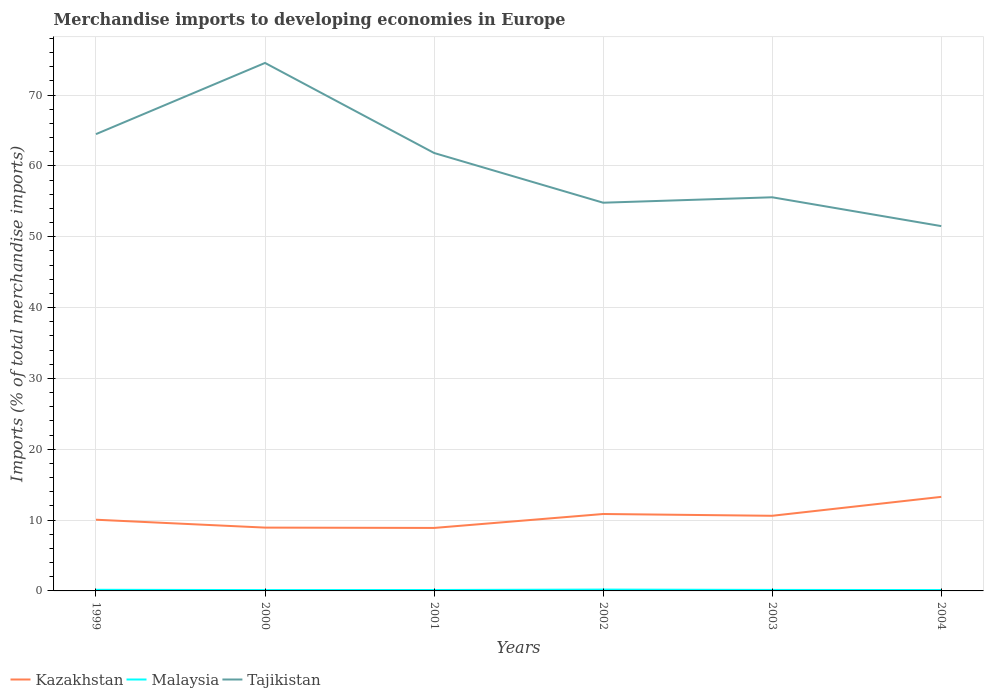Is the number of lines equal to the number of legend labels?
Offer a terse response. Yes. Across all years, what is the maximum percentage total merchandise imports in Malaysia?
Offer a very short reply. 0.12. In which year was the percentage total merchandise imports in Malaysia maximum?
Your response must be concise. 2000. What is the total percentage total merchandise imports in Malaysia in the graph?
Your response must be concise. -0. What is the difference between the highest and the second highest percentage total merchandise imports in Tajikistan?
Give a very brief answer. 23.04. What is the difference between the highest and the lowest percentage total merchandise imports in Malaysia?
Make the answer very short. 2. Is the percentage total merchandise imports in Tajikistan strictly greater than the percentage total merchandise imports in Malaysia over the years?
Keep it short and to the point. No. Are the values on the major ticks of Y-axis written in scientific E-notation?
Ensure brevity in your answer.  No. Where does the legend appear in the graph?
Offer a terse response. Bottom left. How many legend labels are there?
Provide a short and direct response. 3. How are the legend labels stacked?
Ensure brevity in your answer.  Horizontal. What is the title of the graph?
Provide a short and direct response. Merchandise imports to developing economies in Europe. What is the label or title of the X-axis?
Make the answer very short. Years. What is the label or title of the Y-axis?
Offer a very short reply. Imports (% of total merchandise imports). What is the Imports (% of total merchandise imports) of Kazakhstan in 1999?
Provide a short and direct response. 10.05. What is the Imports (% of total merchandise imports) of Malaysia in 1999?
Ensure brevity in your answer.  0.16. What is the Imports (% of total merchandise imports) of Tajikistan in 1999?
Give a very brief answer. 64.49. What is the Imports (% of total merchandise imports) in Kazakhstan in 2000?
Offer a very short reply. 8.94. What is the Imports (% of total merchandise imports) in Malaysia in 2000?
Your answer should be very brief. 0.12. What is the Imports (% of total merchandise imports) of Tajikistan in 2000?
Your answer should be compact. 74.54. What is the Imports (% of total merchandise imports) in Kazakhstan in 2001?
Provide a succinct answer. 8.89. What is the Imports (% of total merchandise imports) of Malaysia in 2001?
Your answer should be very brief. 0.13. What is the Imports (% of total merchandise imports) in Tajikistan in 2001?
Offer a terse response. 61.83. What is the Imports (% of total merchandise imports) in Kazakhstan in 2002?
Provide a short and direct response. 10.86. What is the Imports (% of total merchandise imports) of Malaysia in 2002?
Keep it short and to the point. 0.19. What is the Imports (% of total merchandise imports) in Tajikistan in 2002?
Your answer should be compact. 54.81. What is the Imports (% of total merchandise imports) in Kazakhstan in 2003?
Ensure brevity in your answer.  10.61. What is the Imports (% of total merchandise imports) of Malaysia in 2003?
Provide a short and direct response. 0.14. What is the Imports (% of total merchandise imports) in Tajikistan in 2003?
Provide a succinct answer. 55.57. What is the Imports (% of total merchandise imports) in Kazakhstan in 2004?
Give a very brief answer. 13.28. What is the Imports (% of total merchandise imports) of Malaysia in 2004?
Your answer should be very brief. 0.12. What is the Imports (% of total merchandise imports) of Tajikistan in 2004?
Provide a short and direct response. 51.5. Across all years, what is the maximum Imports (% of total merchandise imports) in Kazakhstan?
Provide a short and direct response. 13.28. Across all years, what is the maximum Imports (% of total merchandise imports) in Malaysia?
Keep it short and to the point. 0.19. Across all years, what is the maximum Imports (% of total merchandise imports) of Tajikistan?
Your answer should be very brief. 74.54. Across all years, what is the minimum Imports (% of total merchandise imports) in Kazakhstan?
Your answer should be very brief. 8.89. Across all years, what is the minimum Imports (% of total merchandise imports) in Malaysia?
Keep it short and to the point. 0.12. Across all years, what is the minimum Imports (% of total merchandise imports) of Tajikistan?
Offer a very short reply. 51.5. What is the total Imports (% of total merchandise imports) of Kazakhstan in the graph?
Your answer should be compact. 62.63. What is the total Imports (% of total merchandise imports) of Malaysia in the graph?
Ensure brevity in your answer.  0.86. What is the total Imports (% of total merchandise imports) of Tajikistan in the graph?
Offer a very short reply. 362.75. What is the difference between the Imports (% of total merchandise imports) in Kazakhstan in 1999 and that in 2000?
Offer a terse response. 1.11. What is the difference between the Imports (% of total merchandise imports) in Malaysia in 1999 and that in 2000?
Ensure brevity in your answer.  0.04. What is the difference between the Imports (% of total merchandise imports) in Tajikistan in 1999 and that in 2000?
Make the answer very short. -10.05. What is the difference between the Imports (% of total merchandise imports) in Kazakhstan in 1999 and that in 2001?
Make the answer very short. 1.16. What is the difference between the Imports (% of total merchandise imports) of Malaysia in 1999 and that in 2001?
Provide a succinct answer. 0.03. What is the difference between the Imports (% of total merchandise imports) of Tajikistan in 1999 and that in 2001?
Keep it short and to the point. 2.66. What is the difference between the Imports (% of total merchandise imports) of Kazakhstan in 1999 and that in 2002?
Offer a very short reply. -0.81. What is the difference between the Imports (% of total merchandise imports) of Malaysia in 1999 and that in 2002?
Offer a terse response. -0.03. What is the difference between the Imports (% of total merchandise imports) in Tajikistan in 1999 and that in 2002?
Provide a succinct answer. 9.68. What is the difference between the Imports (% of total merchandise imports) of Kazakhstan in 1999 and that in 2003?
Ensure brevity in your answer.  -0.56. What is the difference between the Imports (% of total merchandise imports) in Malaysia in 1999 and that in 2003?
Give a very brief answer. 0.02. What is the difference between the Imports (% of total merchandise imports) in Tajikistan in 1999 and that in 2003?
Offer a very short reply. 8.91. What is the difference between the Imports (% of total merchandise imports) of Kazakhstan in 1999 and that in 2004?
Give a very brief answer. -3.23. What is the difference between the Imports (% of total merchandise imports) of Malaysia in 1999 and that in 2004?
Your answer should be compact. 0.03. What is the difference between the Imports (% of total merchandise imports) of Tajikistan in 1999 and that in 2004?
Make the answer very short. 12.98. What is the difference between the Imports (% of total merchandise imports) of Kazakhstan in 2000 and that in 2001?
Keep it short and to the point. 0.05. What is the difference between the Imports (% of total merchandise imports) of Malaysia in 2000 and that in 2001?
Offer a very short reply. -0.01. What is the difference between the Imports (% of total merchandise imports) in Tajikistan in 2000 and that in 2001?
Offer a very short reply. 12.71. What is the difference between the Imports (% of total merchandise imports) of Kazakhstan in 2000 and that in 2002?
Keep it short and to the point. -1.92. What is the difference between the Imports (% of total merchandise imports) in Malaysia in 2000 and that in 2002?
Give a very brief answer. -0.07. What is the difference between the Imports (% of total merchandise imports) in Tajikistan in 2000 and that in 2002?
Offer a terse response. 19.73. What is the difference between the Imports (% of total merchandise imports) of Kazakhstan in 2000 and that in 2003?
Provide a short and direct response. -1.67. What is the difference between the Imports (% of total merchandise imports) of Malaysia in 2000 and that in 2003?
Give a very brief answer. -0.02. What is the difference between the Imports (% of total merchandise imports) in Tajikistan in 2000 and that in 2003?
Your response must be concise. 18.97. What is the difference between the Imports (% of total merchandise imports) in Kazakhstan in 2000 and that in 2004?
Keep it short and to the point. -4.34. What is the difference between the Imports (% of total merchandise imports) in Malaysia in 2000 and that in 2004?
Offer a terse response. -0. What is the difference between the Imports (% of total merchandise imports) in Tajikistan in 2000 and that in 2004?
Your answer should be very brief. 23.04. What is the difference between the Imports (% of total merchandise imports) in Kazakhstan in 2001 and that in 2002?
Keep it short and to the point. -1.97. What is the difference between the Imports (% of total merchandise imports) of Malaysia in 2001 and that in 2002?
Keep it short and to the point. -0.06. What is the difference between the Imports (% of total merchandise imports) in Tajikistan in 2001 and that in 2002?
Your response must be concise. 7.02. What is the difference between the Imports (% of total merchandise imports) of Kazakhstan in 2001 and that in 2003?
Offer a terse response. -1.72. What is the difference between the Imports (% of total merchandise imports) in Malaysia in 2001 and that in 2003?
Give a very brief answer. -0.01. What is the difference between the Imports (% of total merchandise imports) of Tajikistan in 2001 and that in 2003?
Provide a succinct answer. 6.25. What is the difference between the Imports (% of total merchandise imports) in Kazakhstan in 2001 and that in 2004?
Ensure brevity in your answer.  -4.39. What is the difference between the Imports (% of total merchandise imports) in Malaysia in 2001 and that in 2004?
Provide a succinct answer. 0.01. What is the difference between the Imports (% of total merchandise imports) of Tajikistan in 2001 and that in 2004?
Make the answer very short. 10.32. What is the difference between the Imports (% of total merchandise imports) of Kazakhstan in 2002 and that in 2003?
Your answer should be very brief. 0.25. What is the difference between the Imports (% of total merchandise imports) of Malaysia in 2002 and that in 2003?
Your answer should be compact. 0.05. What is the difference between the Imports (% of total merchandise imports) in Tajikistan in 2002 and that in 2003?
Provide a short and direct response. -0.77. What is the difference between the Imports (% of total merchandise imports) of Kazakhstan in 2002 and that in 2004?
Provide a succinct answer. -2.42. What is the difference between the Imports (% of total merchandise imports) of Malaysia in 2002 and that in 2004?
Keep it short and to the point. 0.07. What is the difference between the Imports (% of total merchandise imports) in Tajikistan in 2002 and that in 2004?
Ensure brevity in your answer.  3.3. What is the difference between the Imports (% of total merchandise imports) of Kazakhstan in 2003 and that in 2004?
Make the answer very short. -2.67. What is the difference between the Imports (% of total merchandise imports) in Malaysia in 2003 and that in 2004?
Provide a succinct answer. 0.02. What is the difference between the Imports (% of total merchandise imports) in Tajikistan in 2003 and that in 2004?
Provide a short and direct response. 4.07. What is the difference between the Imports (% of total merchandise imports) in Kazakhstan in 1999 and the Imports (% of total merchandise imports) in Malaysia in 2000?
Make the answer very short. 9.93. What is the difference between the Imports (% of total merchandise imports) of Kazakhstan in 1999 and the Imports (% of total merchandise imports) of Tajikistan in 2000?
Your response must be concise. -64.49. What is the difference between the Imports (% of total merchandise imports) of Malaysia in 1999 and the Imports (% of total merchandise imports) of Tajikistan in 2000?
Offer a very short reply. -74.38. What is the difference between the Imports (% of total merchandise imports) in Kazakhstan in 1999 and the Imports (% of total merchandise imports) in Malaysia in 2001?
Your answer should be very brief. 9.92. What is the difference between the Imports (% of total merchandise imports) of Kazakhstan in 1999 and the Imports (% of total merchandise imports) of Tajikistan in 2001?
Provide a short and direct response. -51.77. What is the difference between the Imports (% of total merchandise imports) in Malaysia in 1999 and the Imports (% of total merchandise imports) in Tajikistan in 2001?
Give a very brief answer. -61.67. What is the difference between the Imports (% of total merchandise imports) of Kazakhstan in 1999 and the Imports (% of total merchandise imports) of Malaysia in 2002?
Offer a very short reply. 9.86. What is the difference between the Imports (% of total merchandise imports) in Kazakhstan in 1999 and the Imports (% of total merchandise imports) in Tajikistan in 2002?
Your answer should be very brief. -44.76. What is the difference between the Imports (% of total merchandise imports) in Malaysia in 1999 and the Imports (% of total merchandise imports) in Tajikistan in 2002?
Provide a succinct answer. -54.65. What is the difference between the Imports (% of total merchandise imports) in Kazakhstan in 1999 and the Imports (% of total merchandise imports) in Malaysia in 2003?
Give a very brief answer. 9.91. What is the difference between the Imports (% of total merchandise imports) of Kazakhstan in 1999 and the Imports (% of total merchandise imports) of Tajikistan in 2003?
Your response must be concise. -45.52. What is the difference between the Imports (% of total merchandise imports) in Malaysia in 1999 and the Imports (% of total merchandise imports) in Tajikistan in 2003?
Provide a short and direct response. -55.42. What is the difference between the Imports (% of total merchandise imports) of Kazakhstan in 1999 and the Imports (% of total merchandise imports) of Malaysia in 2004?
Provide a succinct answer. 9.93. What is the difference between the Imports (% of total merchandise imports) in Kazakhstan in 1999 and the Imports (% of total merchandise imports) in Tajikistan in 2004?
Make the answer very short. -41.45. What is the difference between the Imports (% of total merchandise imports) of Malaysia in 1999 and the Imports (% of total merchandise imports) of Tajikistan in 2004?
Offer a very short reply. -51.35. What is the difference between the Imports (% of total merchandise imports) of Kazakhstan in 2000 and the Imports (% of total merchandise imports) of Malaysia in 2001?
Offer a very short reply. 8.81. What is the difference between the Imports (% of total merchandise imports) of Kazakhstan in 2000 and the Imports (% of total merchandise imports) of Tajikistan in 2001?
Offer a terse response. -52.89. What is the difference between the Imports (% of total merchandise imports) of Malaysia in 2000 and the Imports (% of total merchandise imports) of Tajikistan in 2001?
Your answer should be compact. -61.71. What is the difference between the Imports (% of total merchandise imports) in Kazakhstan in 2000 and the Imports (% of total merchandise imports) in Malaysia in 2002?
Provide a succinct answer. 8.75. What is the difference between the Imports (% of total merchandise imports) in Kazakhstan in 2000 and the Imports (% of total merchandise imports) in Tajikistan in 2002?
Provide a short and direct response. -45.87. What is the difference between the Imports (% of total merchandise imports) in Malaysia in 2000 and the Imports (% of total merchandise imports) in Tajikistan in 2002?
Provide a short and direct response. -54.69. What is the difference between the Imports (% of total merchandise imports) of Kazakhstan in 2000 and the Imports (% of total merchandise imports) of Malaysia in 2003?
Ensure brevity in your answer.  8.8. What is the difference between the Imports (% of total merchandise imports) of Kazakhstan in 2000 and the Imports (% of total merchandise imports) of Tajikistan in 2003?
Your answer should be very brief. -46.64. What is the difference between the Imports (% of total merchandise imports) of Malaysia in 2000 and the Imports (% of total merchandise imports) of Tajikistan in 2003?
Provide a short and direct response. -55.45. What is the difference between the Imports (% of total merchandise imports) in Kazakhstan in 2000 and the Imports (% of total merchandise imports) in Malaysia in 2004?
Give a very brief answer. 8.82. What is the difference between the Imports (% of total merchandise imports) in Kazakhstan in 2000 and the Imports (% of total merchandise imports) in Tajikistan in 2004?
Provide a succinct answer. -42.57. What is the difference between the Imports (% of total merchandise imports) in Malaysia in 2000 and the Imports (% of total merchandise imports) in Tajikistan in 2004?
Make the answer very short. -51.38. What is the difference between the Imports (% of total merchandise imports) in Kazakhstan in 2001 and the Imports (% of total merchandise imports) in Malaysia in 2002?
Give a very brief answer. 8.7. What is the difference between the Imports (% of total merchandise imports) of Kazakhstan in 2001 and the Imports (% of total merchandise imports) of Tajikistan in 2002?
Keep it short and to the point. -45.92. What is the difference between the Imports (% of total merchandise imports) of Malaysia in 2001 and the Imports (% of total merchandise imports) of Tajikistan in 2002?
Ensure brevity in your answer.  -54.68. What is the difference between the Imports (% of total merchandise imports) of Kazakhstan in 2001 and the Imports (% of total merchandise imports) of Malaysia in 2003?
Make the answer very short. 8.75. What is the difference between the Imports (% of total merchandise imports) of Kazakhstan in 2001 and the Imports (% of total merchandise imports) of Tajikistan in 2003?
Keep it short and to the point. -46.68. What is the difference between the Imports (% of total merchandise imports) of Malaysia in 2001 and the Imports (% of total merchandise imports) of Tajikistan in 2003?
Offer a terse response. -55.44. What is the difference between the Imports (% of total merchandise imports) in Kazakhstan in 2001 and the Imports (% of total merchandise imports) in Malaysia in 2004?
Keep it short and to the point. 8.77. What is the difference between the Imports (% of total merchandise imports) in Kazakhstan in 2001 and the Imports (% of total merchandise imports) in Tajikistan in 2004?
Give a very brief answer. -42.61. What is the difference between the Imports (% of total merchandise imports) in Malaysia in 2001 and the Imports (% of total merchandise imports) in Tajikistan in 2004?
Your response must be concise. -51.37. What is the difference between the Imports (% of total merchandise imports) of Kazakhstan in 2002 and the Imports (% of total merchandise imports) of Malaysia in 2003?
Your response must be concise. 10.72. What is the difference between the Imports (% of total merchandise imports) in Kazakhstan in 2002 and the Imports (% of total merchandise imports) in Tajikistan in 2003?
Give a very brief answer. -44.71. What is the difference between the Imports (% of total merchandise imports) in Malaysia in 2002 and the Imports (% of total merchandise imports) in Tajikistan in 2003?
Provide a succinct answer. -55.38. What is the difference between the Imports (% of total merchandise imports) in Kazakhstan in 2002 and the Imports (% of total merchandise imports) in Malaysia in 2004?
Offer a very short reply. 10.74. What is the difference between the Imports (% of total merchandise imports) of Kazakhstan in 2002 and the Imports (% of total merchandise imports) of Tajikistan in 2004?
Provide a short and direct response. -40.64. What is the difference between the Imports (% of total merchandise imports) of Malaysia in 2002 and the Imports (% of total merchandise imports) of Tajikistan in 2004?
Ensure brevity in your answer.  -51.31. What is the difference between the Imports (% of total merchandise imports) in Kazakhstan in 2003 and the Imports (% of total merchandise imports) in Malaysia in 2004?
Your answer should be compact. 10.48. What is the difference between the Imports (% of total merchandise imports) in Kazakhstan in 2003 and the Imports (% of total merchandise imports) in Tajikistan in 2004?
Give a very brief answer. -40.9. What is the difference between the Imports (% of total merchandise imports) of Malaysia in 2003 and the Imports (% of total merchandise imports) of Tajikistan in 2004?
Ensure brevity in your answer.  -51.36. What is the average Imports (% of total merchandise imports) in Kazakhstan per year?
Give a very brief answer. 10.44. What is the average Imports (% of total merchandise imports) in Malaysia per year?
Ensure brevity in your answer.  0.14. What is the average Imports (% of total merchandise imports) of Tajikistan per year?
Provide a succinct answer. 60.46. In the year 1999, what is the difference between the Imports (% of total merchandise imports) in Kazakhstan and Imports (% of total merchandise imports) in Malaysia?
Your answer should be very brief. 9.89. In the year 1999, what is the difference between the Imports (% of total merchandise imports) in Kazakhstan and Imports (% of total merchandise imports) in Tajikistan?
Make the answer very short. -54.44. In the year 1999, what is the difference between the Imports (% of total merchandise imports) in Malaysia and Imports (% of total merchandise imports) in Tajikistan?
Give a very brief answer. -64.33. In the year 2000, what is the difference between the Imports (% of total merchandise imports) of Kazakhstan and Imports (% of total merchandise imports) of Malaysia?
Your answer should be very brief. 8.82. In the year 2000, what is the difference between the Imports (% of total merchandise imports) in Kazakhstan and Imports (% of total merchandise imports) in Tajikistan?
Make the answer very short. -65.6. In the year 2000, what is the difference between the Imports (% of total merchandise imports) of Malaysia and Imports (% of total merchandise imports) of Tajikistan?
Your answer should be compact. -74.42. In the year 2001, what is the difference between the Imports (% of total merchandise imports) in Kazakhstan and Imports (% of total merchandise imports) in Malaysia?
Your answer should be very brief. 8.76. In the year 2001, what is the difference between the Imports (% of total merchandise imports) in Kazakhstan and Imports (% of total merchandise imports) in Tajikistan?
Give a very brief answer. -52.94. In the year 2001, what is the difference between the Imports (% of total merchandise imports) in Malaysia and Imports (% of total merchandise imports) in Tajikistan?
Offer a terse response. -61.7. In the year 2002, what is the difference between the Imports (% of total merchandise imports) in Kazakhstan and Imports (% of total merchandise imports) in Malaysia?
Provide a succinct answer. 10.67. In the year 2002, what is the difference between the Imports (% of total merchandise imports) in Kazakhstan and Imports (% of total merchandise imports) in Tajikistan?
Ensure brevity in your answer.  -43.95. In the year 2002, what is the difference between the Imports (% of total merchandise imports) in Malaysia and Imports (% of total merchandise imports) in Tajikistan?
Offer a very short reply. -54.62. In the year 2003, what is the difference between the Imports (% of total merchandise imports) in Kazakhstan and Imports (% of total merchandise imports) in Malaysia?
Provide a short and direct response. 10.47. In the year 2003, what is the difference between the Imports (% of total merchandise imports) in Kazakhstan and Imports (% of total merchandise imports) in Tajikistan?
Provide a succinct answer. -44.97. In the year 2003, what is the difference between the Imports (% of total merchandise imports) of Malaysia and Imports (% of total merchandise imports) of Tajikistan?
Your answer should be compact. -55.43. In the year 2004, what is the difference between the Imports (% of total merchandise imports) in Kazakhstan and Imports (% of total merchandise imports) in Malaysia?
Keep it short and to the point. 13.15. In the year 2004, what is the difference between the Imports (% of total merchandise imports) of Kazakhstan and Imports (% of total merchandise imports) of Tajikistan?
Make the answer very short. -38.23. In the year 2004, what is the difference between the Imports (% of total merchandise imports) in Malaysia and Imports (% of total merchandise imports) in Tajikistan?
Keep it short and to the point. -51.38. What is the ratio of the Imports (% of total merchandise imports) in Kazakhstan in 1999 to that in 2000?
Provide a short and direct response. 1.12. What is the ratio of the Imports (% of total merchandise imports) of Malaysia in 1999 to that in 2000?
Provide a short and direct response. 1.32. What is the ratio of the Imports (% of total merchandise imports) of Tajikistan in 1999 to that in 2000?
Make the answer very short. 0.87. What is the ratio of the Imports (% of total merchandise imports) in Kazakhstan in 1999 to that in 2001?
Offer a very short reply. 1.13. What is the ratio of the Imports (% of total merchandise imports) in Malaysia in 1999 to that in 2001?
Your response must be concise. 1.22. What is the ratio of the Imports (% of total merchandise imports) in Tajikistan in 1999 to that in 2001?
Offer a very short reply. 1.04. What is the ratio of the Imports (% of total merchandise imports) of Kazakhstan in 1999 to that in 2002?
Provide a short and direct response. 0.93. What is the ratio of the Imports (% of total merchandise imports) in Malaysia in 1999 to that in 2002?
Your response must be concise. 0.83. What is the ratio of the Imports (% of total merchandise imports) of Tajikistan in 1999 to that in 2002?
Your answer should be very brief. 1.18. What is the ratio of the Imports (% of total merchandise imports) in Kazakhstan in 1999 to that in 2003?
Offer a terse response. 0.95. What is the ratio of the Imports (% of total merchandise imports) of Malaysia in 1999 to that in 2003?
Your answer should be very brief. 1.12. What is the ratio of the Imports (% of total merchandise imports) in Tajikistan in 1999 to that in 2003?
Your response must be concise. 1.16. What is the ratio of the Imports (% of total merchandise imports) in Kazakhstan in 1999 to that in 2004?
Provide a short and direct response. 0.76. What is the ratio of the Imports (% of total merchandise imports) of Malaysia in 1999 to that in 2004?
Ensure brevity in your answer.  1.27. What is the ratio of the Imports (% of total merchandise imports) in Tajikistan in 1999 to that in 2004?
Provide a succinct answer. 1.25. What is the ratio of the Imports (% of total merchandise imports) in Kazakhstan in 2000 to that in 2001?
Provide a short and direct response. 1.01. What is the ratio of the Imports (% of total merchandise imports) in Malaysia in 2000 to that in 2001?
Your answer should be very brief. 0.92. What is the ratio of the Imports (% of total merchandise imports) in Tajikistan in 2000 to that in 2001?
Make the answer very short. 1.21. What is the ratio of the Imports (% of total merchandise imports) of Kazakhstan in 2000 to that in 2002?
Provide a short and direct response. 0.82. What is the ratio of the Imports (% of total merchandise imports) in Malaysia in 2000 to that in 2002?
Offer a very short reply. 0.63. What is the ratio of the Imports (% of total merchandise imports) in Tajikistan in 2000 to that in 2002?
Make the answer very short. 1.36. What is the ratio of the Imports (% of total merchandise imports) of Kazakhstan in 2000 to that in 2003?
Your response must be concise. 0.84. What is the ratio of the Imports (% of total merchandise imports) of Malaysia in 2000 to that in 2003?
Your response must be concise. 0.85. What is the ratio of the Imports (% of total merchandise imports) of Tajikistan in 2000 to that in 2003?
Your answer should be very brief. 1.34. What is the ratio of the Imports (% of total merchandise imports) in Kazakhstan in 2000 to that in 2004?
Keep it short and to the point. 0.67. What is the ratio of the Imports (% of total merchandise imports) in Malaysia in 2000 to that in 2004?
Make the answer very short. 0.97. What is the ratio of the Imports (% of total merchandise imports) in Tajikistan in 2000 to that in 2004?
Offer a very short reply. 1.45. What is the ratio of the Imports (% of total merchandise imports) of Kazakhstan in 2001 to that in 2002?
Your answer should be very brief. 0.82. What is the ratio of the Imports (% of total merchandise imports) of Malaysia in 2001 to that in 2002?
Offer a terse response. 0.68. What is the ratio of the Imports (% of total merchandise imports) in Tajikistan in 2001 to that in 2002?
Provide a short and direct response. 1.13. What is the ratio of the Imports (% of total merchandise imports) of Kazakhstan in 2001 to that in 2003?
Ensure brevity in your answer.  0.84. What is the ratio of the Imports (% of total merchandise imports) in Malaysia in 2001 to that in 2003?
Your answer should be very brief. 0.92. What is the ratio of the Imports (% of total merchandise imports) in Tajikistan in 2001 to that in 2003?
Your answer should be very brief. 1.11. What is the ratio of the Imports (% of total merchandise imports) of Kazakhstan in 2001 to that in 2004?
Keep it short and to the point. 0.67. What is the ratio of the Imports (% of total merchandise imports) of Malaysia in 2001 to that in 2004?
Your response must be concise. 1.05. What is the ratio of the Imports (% of total merchandise imports) in Tajikistan in 2001 to that in 2004?
Make the answer very short. 1.2. What is the ratio of the Imports (% of total merchandise imports) of Kazakhstan in 2002 to that in 2003?
Provide a short and direct response. 1.02. What is the ratio of the Imports (% of total merchandise imports) of Malaysia in 2002 to that in 2003?
Your response must be concise. 1.34. What is the ratio of the Imports (% of total merchandise imports) in Tajikistan in 2002 to that in 2003?
Provide a succinct answer. 0.99. What is the ratio of the Imports (% of total merchandise imports) in Kazakhstan in 2002 to that in 2004?
Your answer should be very brief. 0.82. What is the ratio of the Imports (% of total merchandise imports) in Malaysia in 2002 to that in 2004?
Provide a short and direct response. 1.53. What is the ratio of the Imports (% of total merchandise imports) in Tajikistan in 2002 to that in 2004?
Give a very brief answer. 1.06. What is the ratio of the Imports (% of total merchandise imports) in Kazakhstan in 2003 to that in 2004?
Provide a short and direct response. 0.8. What is the ratio of the Imports (% of total merchandise imports) of Malaysia in 2003 to that in 2004?
Make the answer very short. 1.14. What is the ratio of the Imports (% of total merchandise imports) of Tajikistan in 2003 to that in 2004?
Keep it short and to the point. 1.08. What is the difference between the highest and the second highest Imports (% of total merchandise imports) of Kazakhstan?
Ensure brevity in your answer.  2.42. What is the difference between the highest and the second highest Imports (% of total merchandise imports) of Malaysia?
Give a very brief answer. 0.03. What is the difference between the highest and the second highest Imports (% of total merchandise imports) in Tajikistan?
Give a very brief answer. 10.05. What is the difference between the highest and the lowest Imports (% of total merchandise imports) of Kazakhstan?
Your answer should be compact. 4.39. What is the difference between the highest and the lowest Imports (% of total merchandise imports) in Malaysia?
Provide a short and direct response. 0.07. What is the difference between the highest and the lowest Imports (% of total merchandise imports) of Tajikistan?
Your answer should be compact. 23.04. 